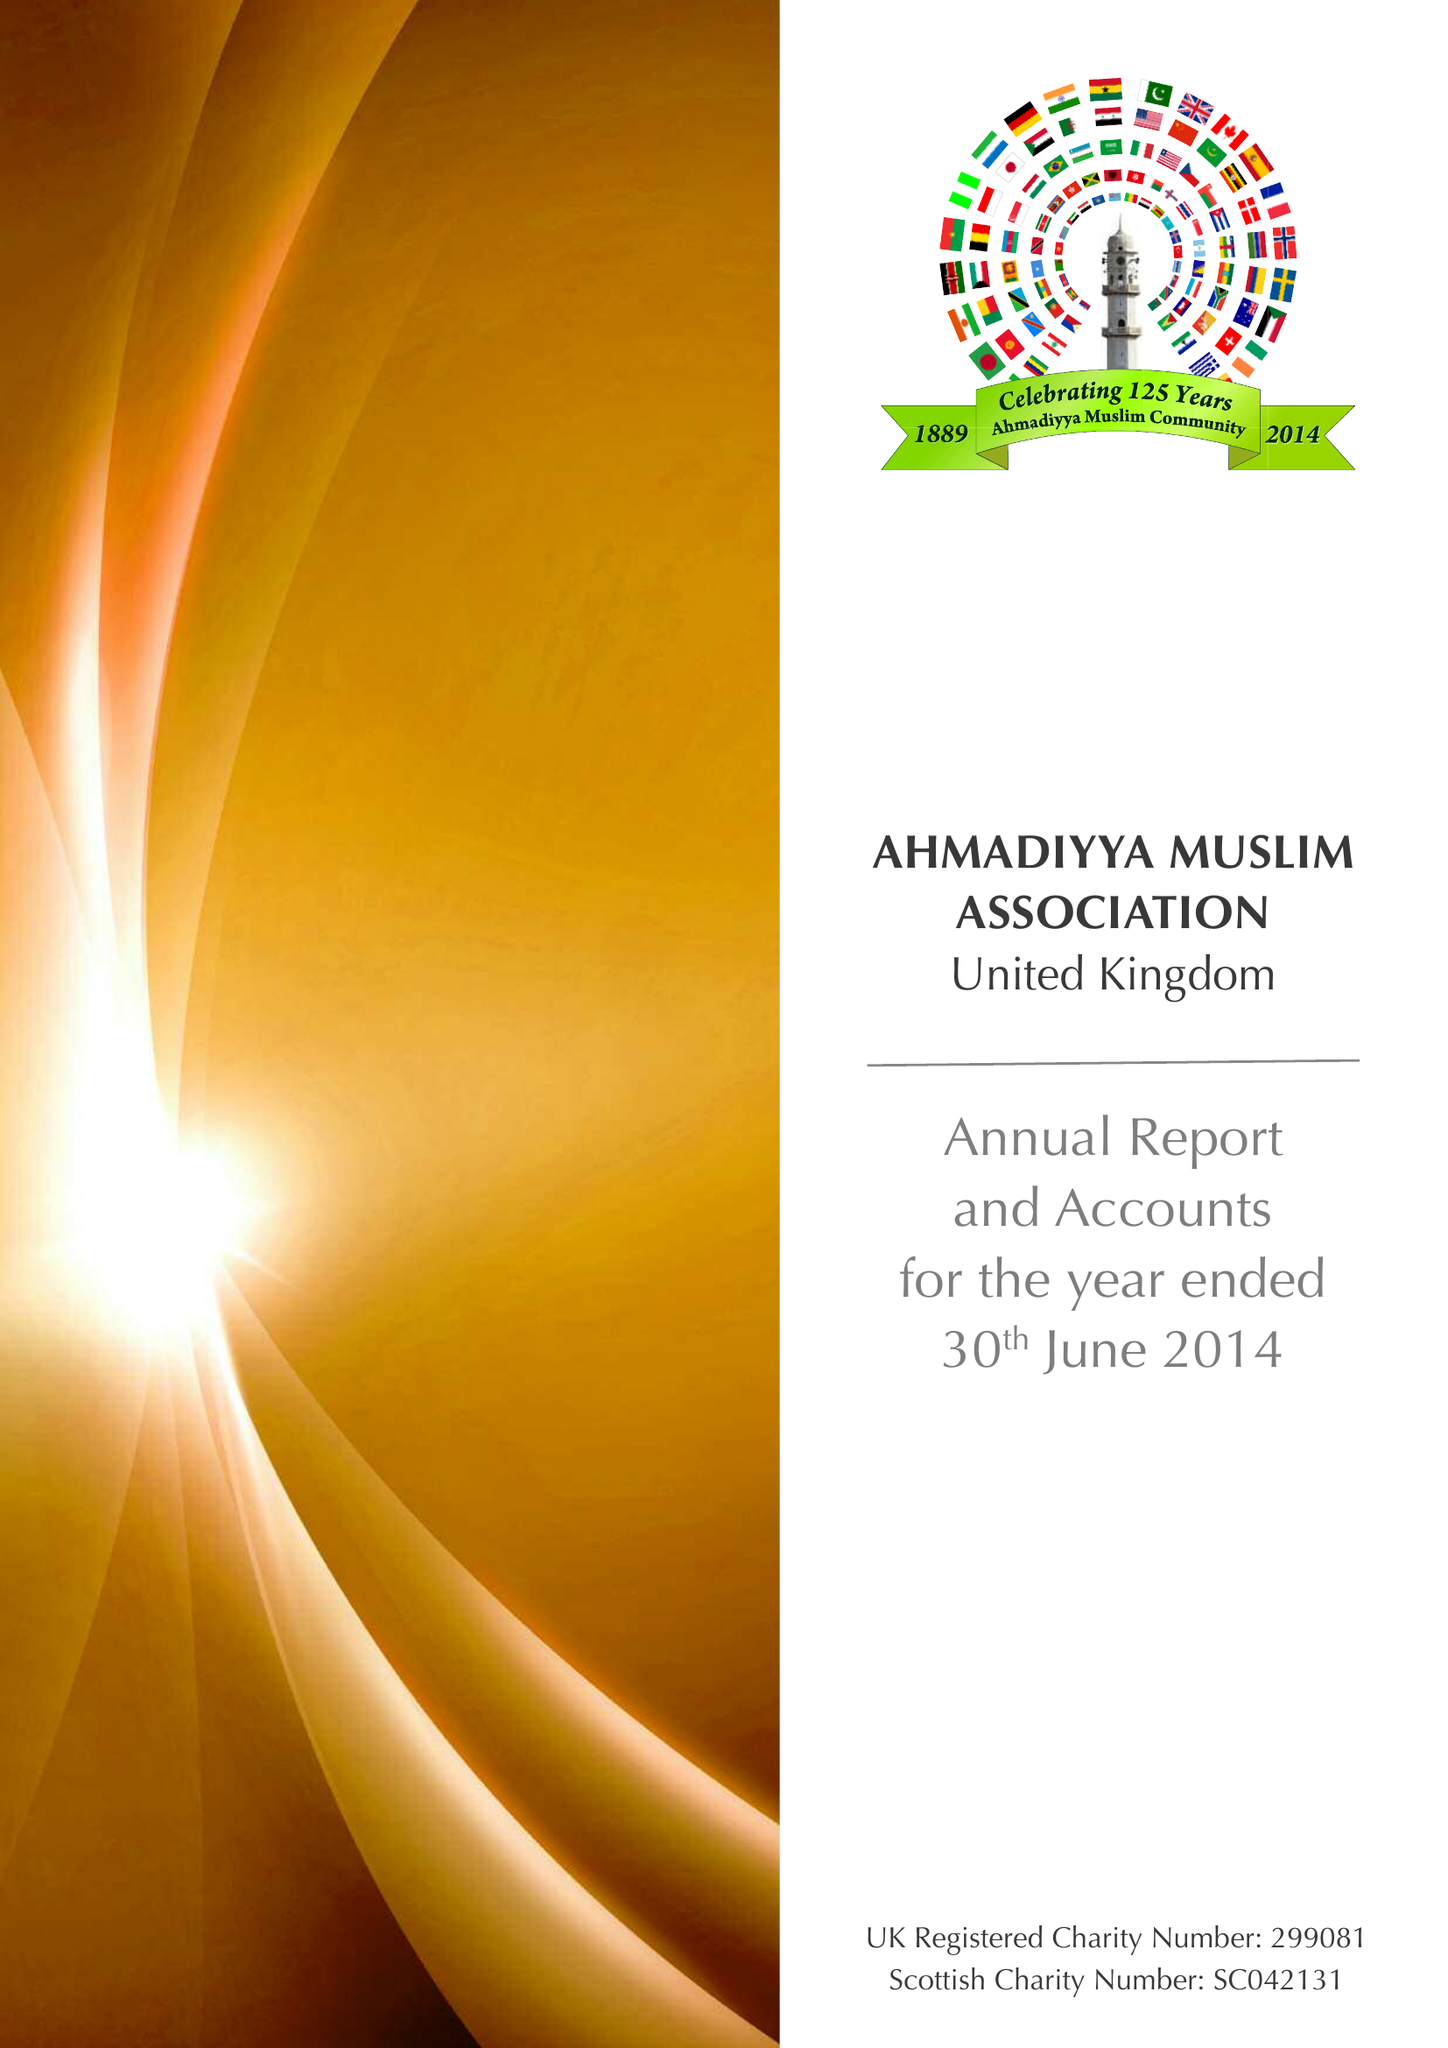What is the value for the charity_number?
Answer the question using a single word or phrase. 299081 